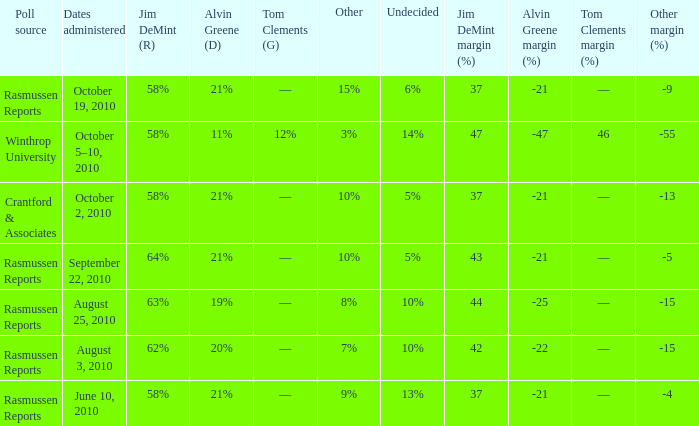Which poll source had an other of 15%? Rasmussen Reports. 